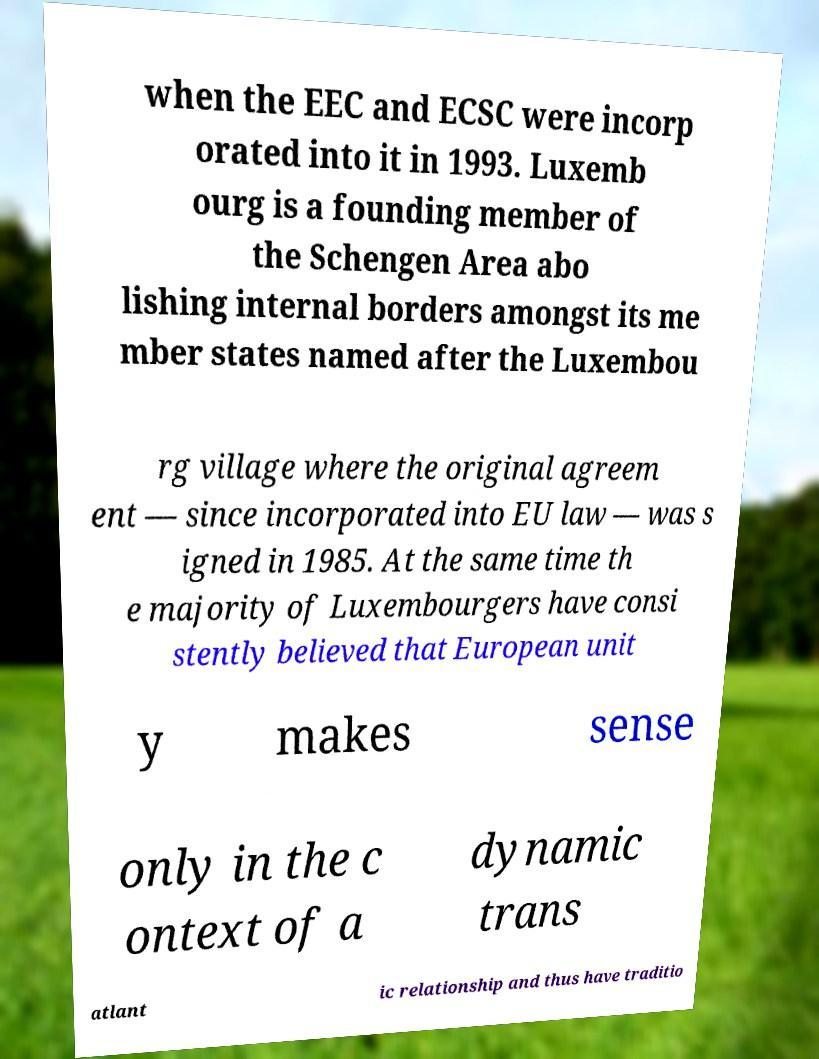Could you assist in decoding the text presented in this image and type it out clearly? when the EEC and ECSC were incorp orated into it in 1993. Luxemb ourg is a founding member of the Schengen Area abo lishing internal borders amongst its me mber states named after the Luxembou rg village where the original agreem ent — since incorporated into EU law — was s igned in 1985. At the same time th e majority of Luxembourgers have consi stently believed that European unit y makes sense only in the c ontext of a dynamic trans atlant ic relationship and thus have traditio 